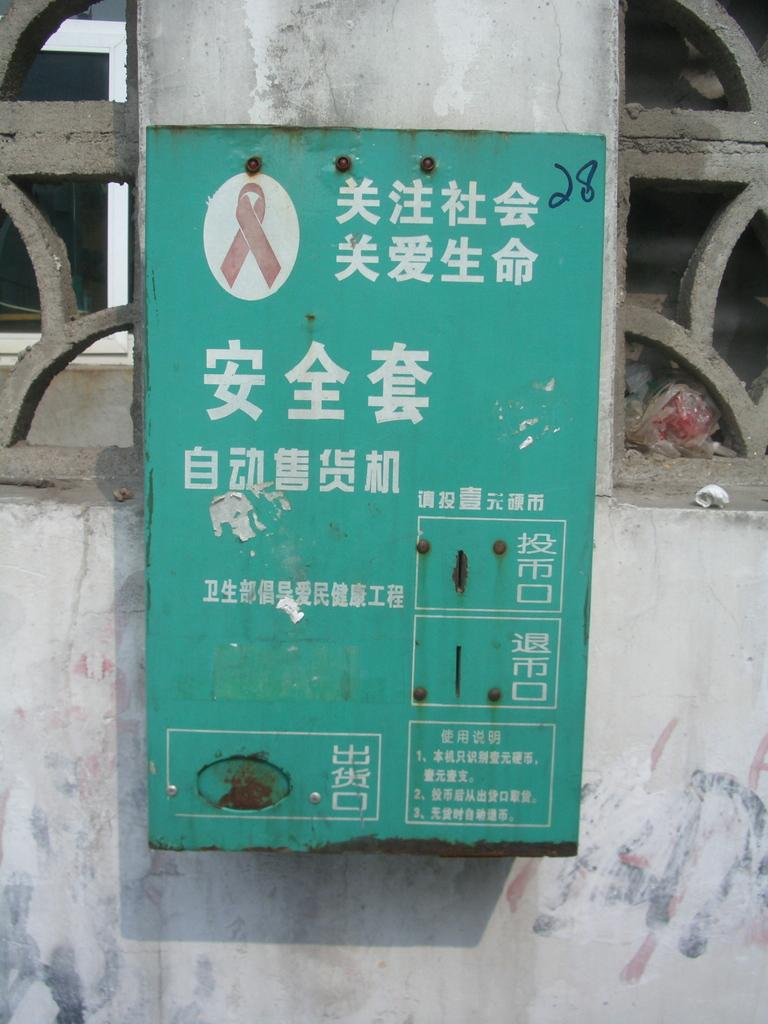What is the main object in the middle of the image? There is a sign board in the middle of the image. Where is the sign board located? The sign board is on a wall. What type of vacation is being advertised on the sign board in the image? There is no information about a vacation or any advertisement on the sign board in the image. 